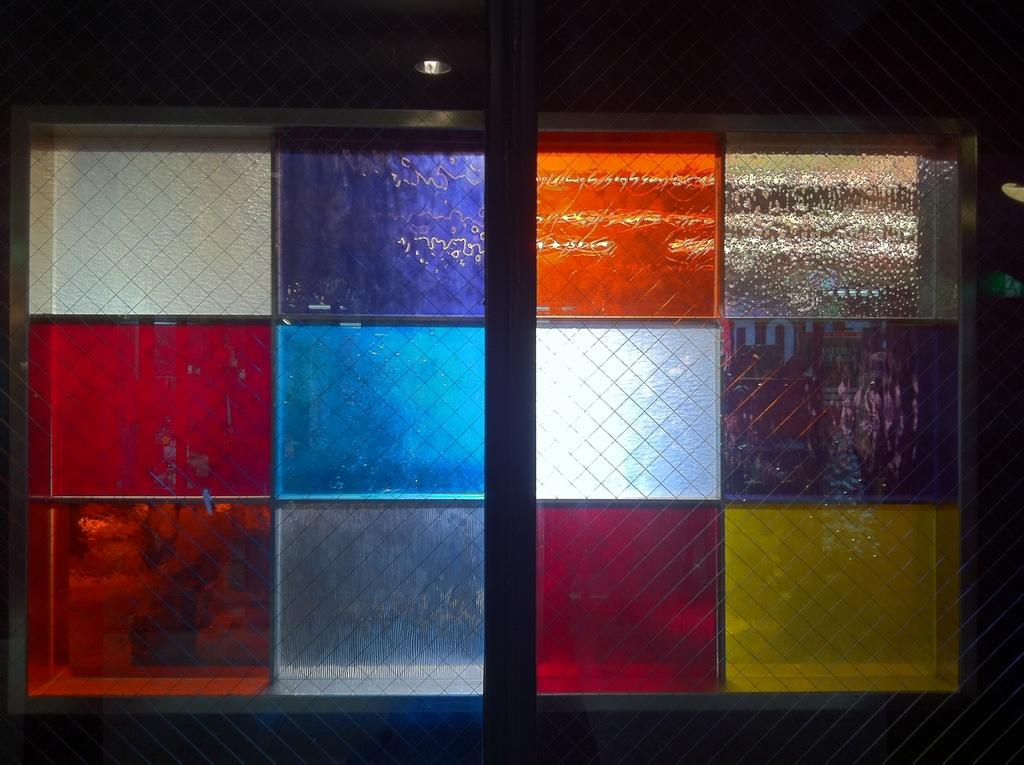What type of structure is present in the image? There is a glass window in the image. What can be observed about the appearance of the glass window? The glass window has colors. What is visible through the glass window? The glass window has light. What role does the grandfather play in the distribution of light through the glass window? There is no mention of a grandfather in the image, and therefore no role for him in the distribution of light through the glass window. 